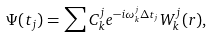Convert formula to latex. <formula><loc_0><loc_0><loc_500><loc_500>\Psi ( t _ { j } ) = \sum C ^ { j } _ { k } e ^ { - i \omega _ { k } ^ { j } \Delta t _ { j } } W _ { k } ^ { j } ( { r } ) ,</formula> 